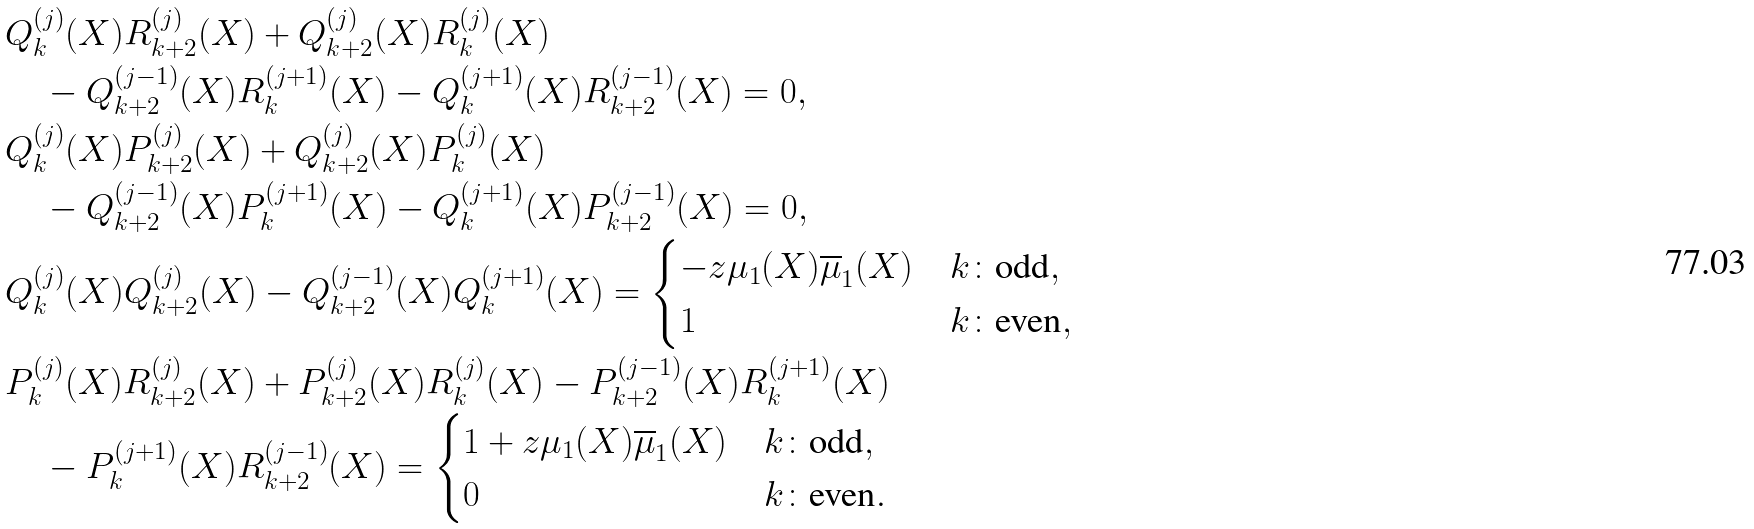<formula> <loc_0><loc_0><loc_500><loc_500>& Q _ { k } ^ { ( j ) } ( X ) R _ { k + 2 } ^ { ( j ) } ( X ) + Q _ { k + 2 } ^ { ( j ) } ( X ) R _ { k } ^ { ( j ) } ( X ) \\ & \quad - Q _ { k + 2 } ^ { ( j - 1 ) } ( X ) R _ { k } ^ { ( j + 1 ) } ( X ) - Q _ { k } ^ { ( j + 1 ) } ( X ) R _ { k + 2 } ^ { ( j - 1 ) } ( X ) = 0 , \\ & Q _ { k } ^ { ( j ) } ( X ) P _ { k + 2 } ^ { ( j ) } ( X ) + Q _ { k + 2 } ^ { ( j ) } ( X ) P _ { k } ^ { ( j ) } ( X ) \\ & \quad - Q _ { k + 2 } ^ { ( j - 1 ) } ( X ) P _ { k } ^ { ( j + 1 ) } ( X ) - Q _ { k } ^ { ( j + 1 ) } ( X ) P _ { k + 2 } ^ { ( j - 1 ) } ( X ) = 0 , \\ & Q _ { k } ^ { ( j ) } ( X ) Q _ { k + 2 } ^ { ( j ) } ( X ) - Q _ { k + 2 } ^ { ( j - 1 ) } ( X ) Q _ { k } ^ { ( j + 1 ) } ( X ) = \begin{cases} - z \mu _ { 1 } ( X ) \overline { \mu } _ { 1 } ( X ) & k \colon \text {odd} , \\ 1 & k \colon \text {even} , \end{cases} \\ & P _ { k } ^ { ( j ) } ( X ) R _ { k + 2 } ^ { ( j ) } ( X ) + P _ { k + 2 } ^ { ( j ) } ( X ) R _ { k } ^ { ( j ) } ( X ) - P _ { k + 2 } ^ { ( j - 1 ) } ( X ) R _ { k } ^ { ( j + 1 ) } ( X ) \\ & \quad - P _ { k } ^ { ( j + 1 ) } ( X ) R _ { k + 2 } ^ { ( j - 1 ) } ( X ) = \begin{cases} 1 + z \mu _ { 1 } ( X ) \overline { \mu } _ { 1 } ( X ) & k \colon \text {odd} , \\ 0 & k \colon \text {even} . \end{cases}</formula> 